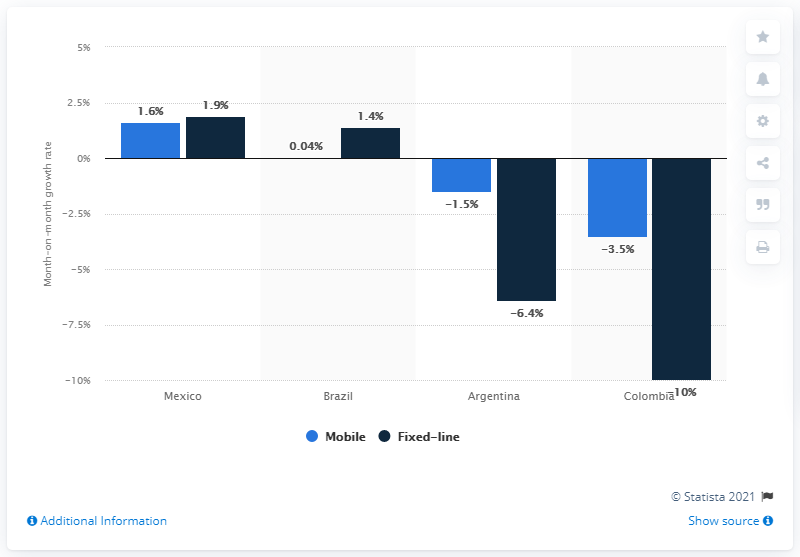Indicate a few pertinent items in this graphic. The speed of fixed-line connections in Brazil increased by 1.4 times between 2005 and 2018. Brazil was the first country in the region to report its first case of COVID-19. Brazil was the first country in the region to report its first case of COVID-19. 